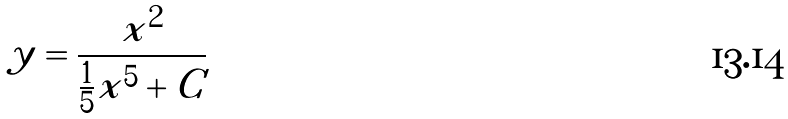Convert formula to latex. <formula><loc_0><loc_0><loc_500><loc_500>y = \frac { x ^ { 2 } } { \frac { 1 } { 5 } x ^ { 5 } + C }</formula> 